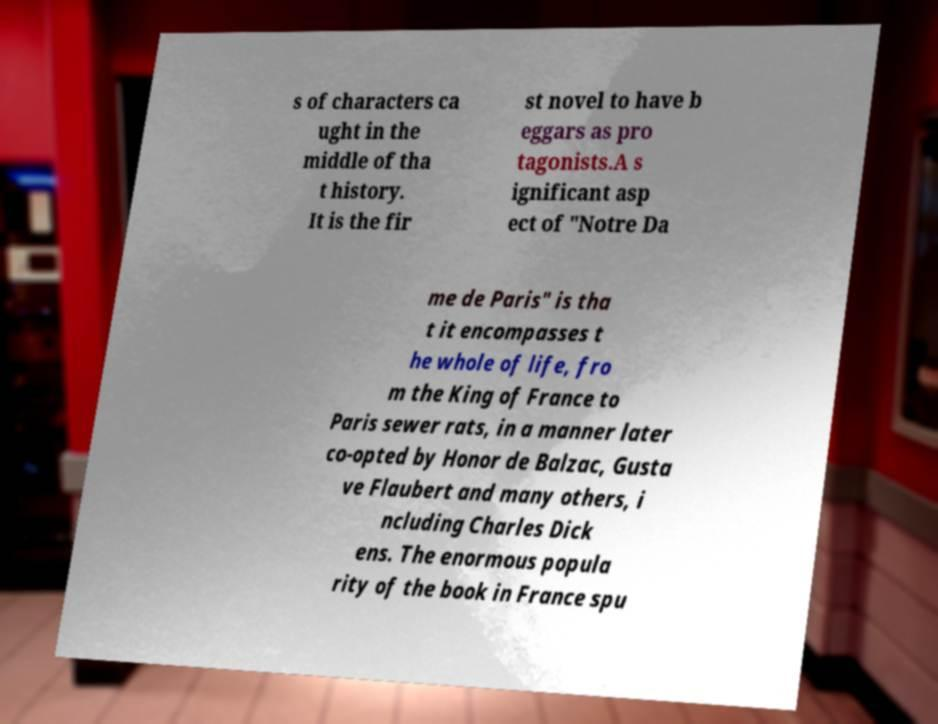Could you assist in decoding the text presented in this image and type it out clearly? s of characters ca ught in the middle of tha t history. It is the fir st novel to have b eggars as pro tagonists.A s ignificant asp ect of "Notre Da me de Paris" is tha t it encompasses t he whole of life, fro m the King of France to Paris sewer rats, in a manner later co-opted by Honor de Balzac, Gusta ve Flaubert and many others, i ncluding Charles Dick ens. The enormous popula rity of the book in France spu 